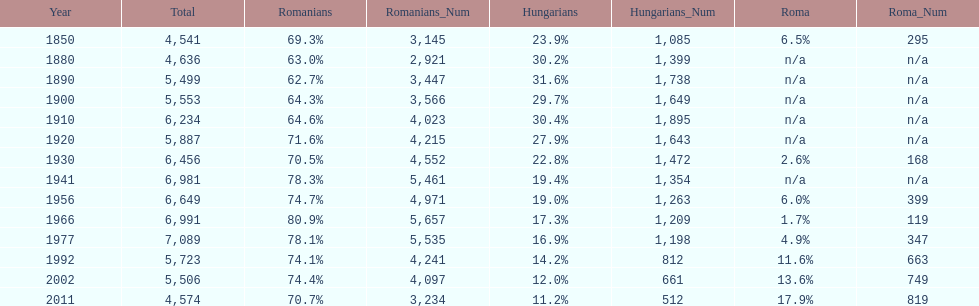What year had the next highest percentage for roma after 2011? 2002. 